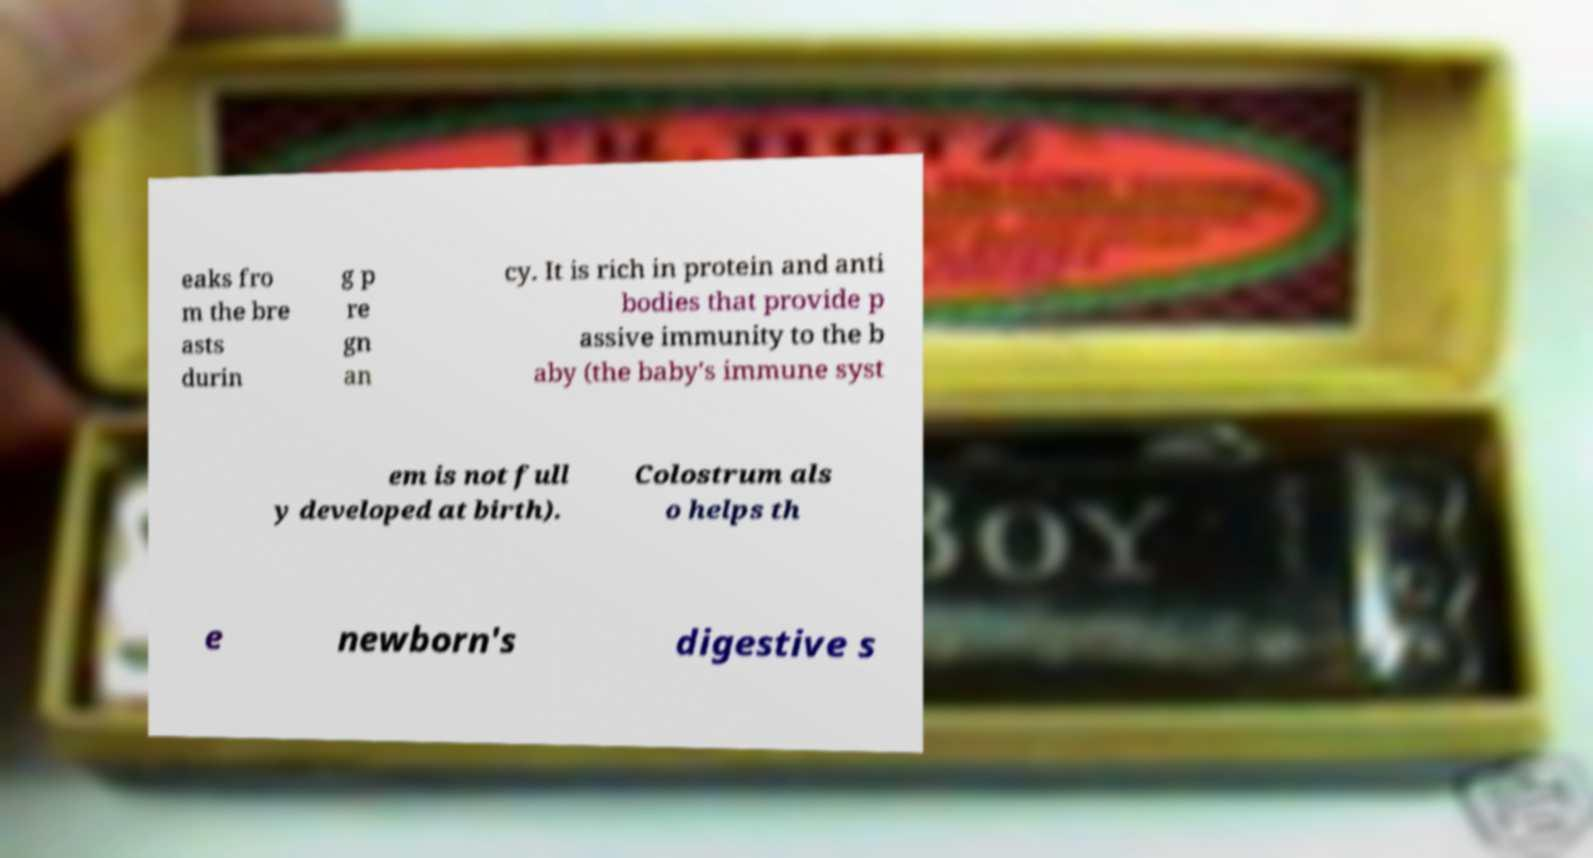For documentation purposes, I need the text within this image transcribed. Could you provide that? eaks fro m the bre asts durin g p re gn an cy. It is rich in protein and anti bodies that provide p assive immunity to the b aby (the baby's immune syst em is not full y developed at birth). Colostrum als o helps th e newborn's digestive s 